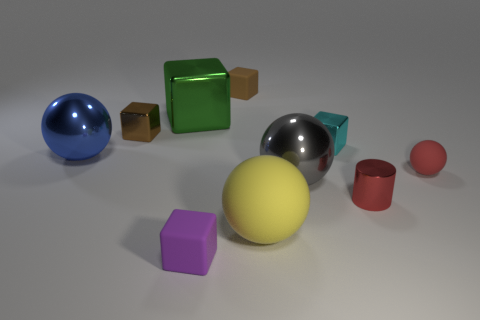Is there anything else that is the same size as the brown rubber thing?
Ensure brevity in your answer.  Yes. The tiny thing behind the brown cube to the left of the brown rubber thing is made of what material?
Offer a terse response. Rubber. Are there the same number of small metallic objects on the left side of the large block and tiny cylinders left of the purple block?
Make the answer very short. No. How many things are either tiny rubber blocks that are in front of the red metal cylinder or cubes in front of the big block?
Your answer should be compact. 3. There is a large sphere that is behind the yellow matte object and to the right of the large blue shiny sphere; what material is it made of?
Your response must be concise. Metal. What is the size of the matte thing behind the large metal object left of the small brown thing that is left of the purple object?
Make the answer very short. Small. Is the number of large cyan balls greater than the number of tiny purple matte cubes?
Ensure brevity in your answer.  No. Does the tiny cube that is in front of the small red metal cylinder have the same material as the red cylinder?
Provide a short and direct response. No. Are there fewer brown cubes than cubes?
Keep it short and to the point. Yes. There is a metallic cube that is behind the small metal thing that is left of the large yellow rubber thing; are there any blue balls that are in front of it?
Your answer should be compact. Yes. 